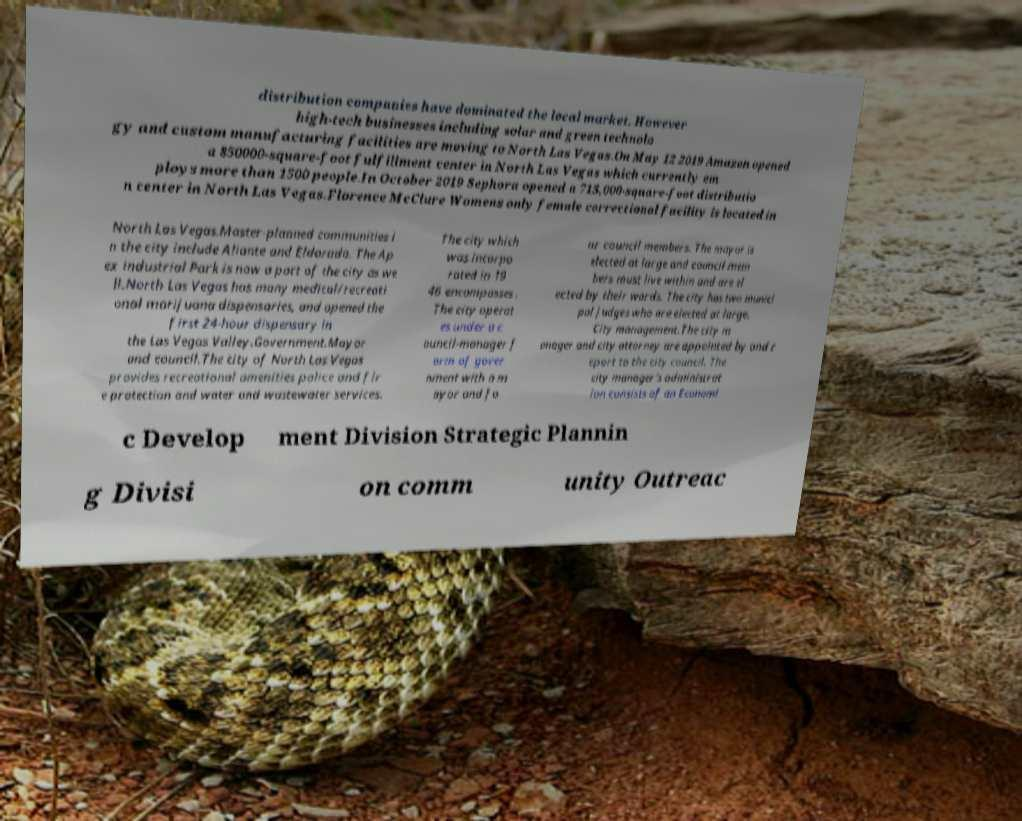Could you assist in decoding the text presented in this image and type it out clearly? distribution companies have dominated the local market. However high-tech businesses including solar and green technolo gy and custom manufacturing facilities are moving to North Las Vegas.On May 12 2019 Amazon opened a 850000-square-foot fulfillment center in North Las Vegas which currently em ploys more than 1500 people.In October 2019 Sephora opened a 715,000-square-foot distributio n center in North Las Vegas.Florence McClure Womens only female correctional facility is located in North Las Vegas.Master-planned communities i n the city include Aliante and Eldorado. The Ap ex industrial Park is now a part of the city as we ll.North Las Vegas has many medical/recreati onal marijuana dispensaries, and opened the first 24-hour dispensary in the Las Vegas Valley.Government.Mayor and council.The city of North Las Vegas provides recreational amenities police and fir e protection and water and wastewater services. The city which was incorpo rated in 19 46 encompasses . The city operat es under a c ouncil-manager f orm of gover nment with a m ayor and fo ur council members. The mayor is elected at large and council mem bers must live within and are el ected by their wards. The city has two munici pal judges who are elected at large. City management.The city m anager and city attorney are appointed by and r eport to the city council. The city manager's administrat ion consists of an Economi c Develop ment Division Strategic Plannin g Divisi on comm unity Outreac 